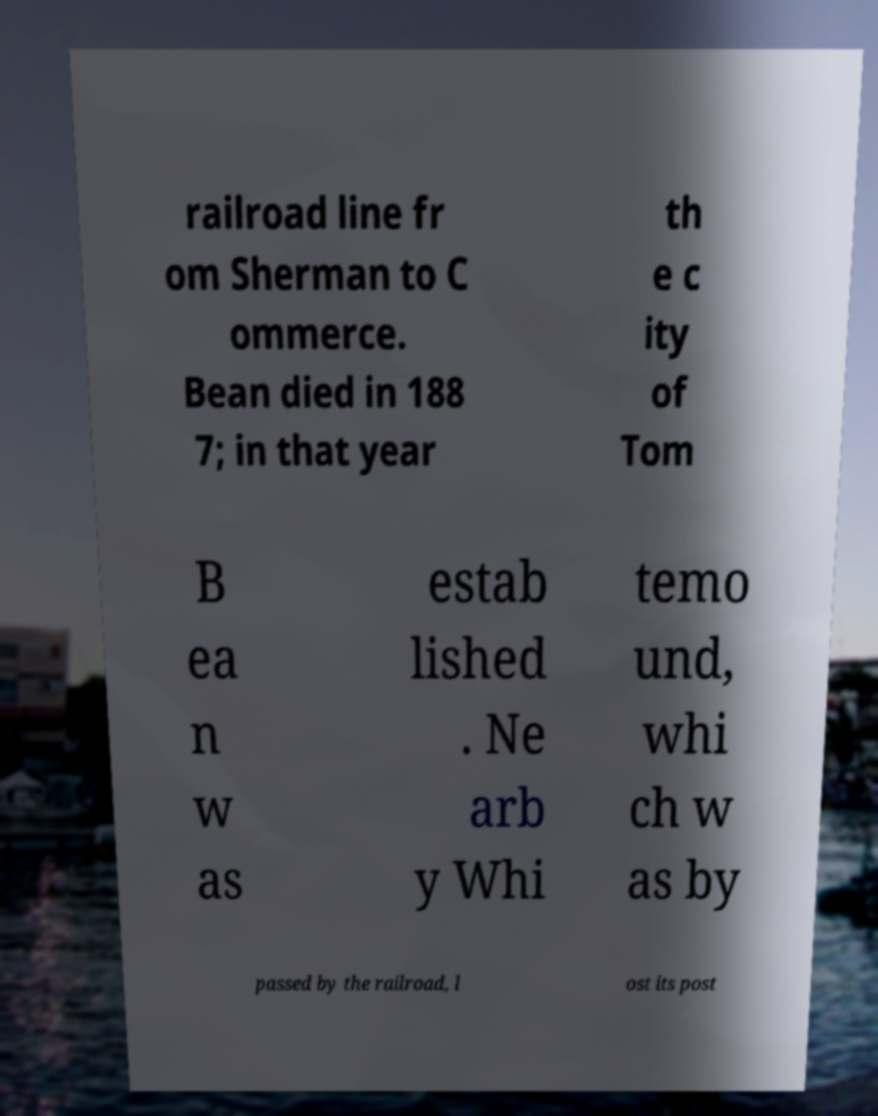Could you extract and type out the text from this image? railroad line fr om Sherman to C ommerce. Bean died in 188 7; in that year th e c ity of Tom B ea n w as estab lished . Ne arb y Whi temo und, whi ch w as by passed by the railroad, l ost its post 